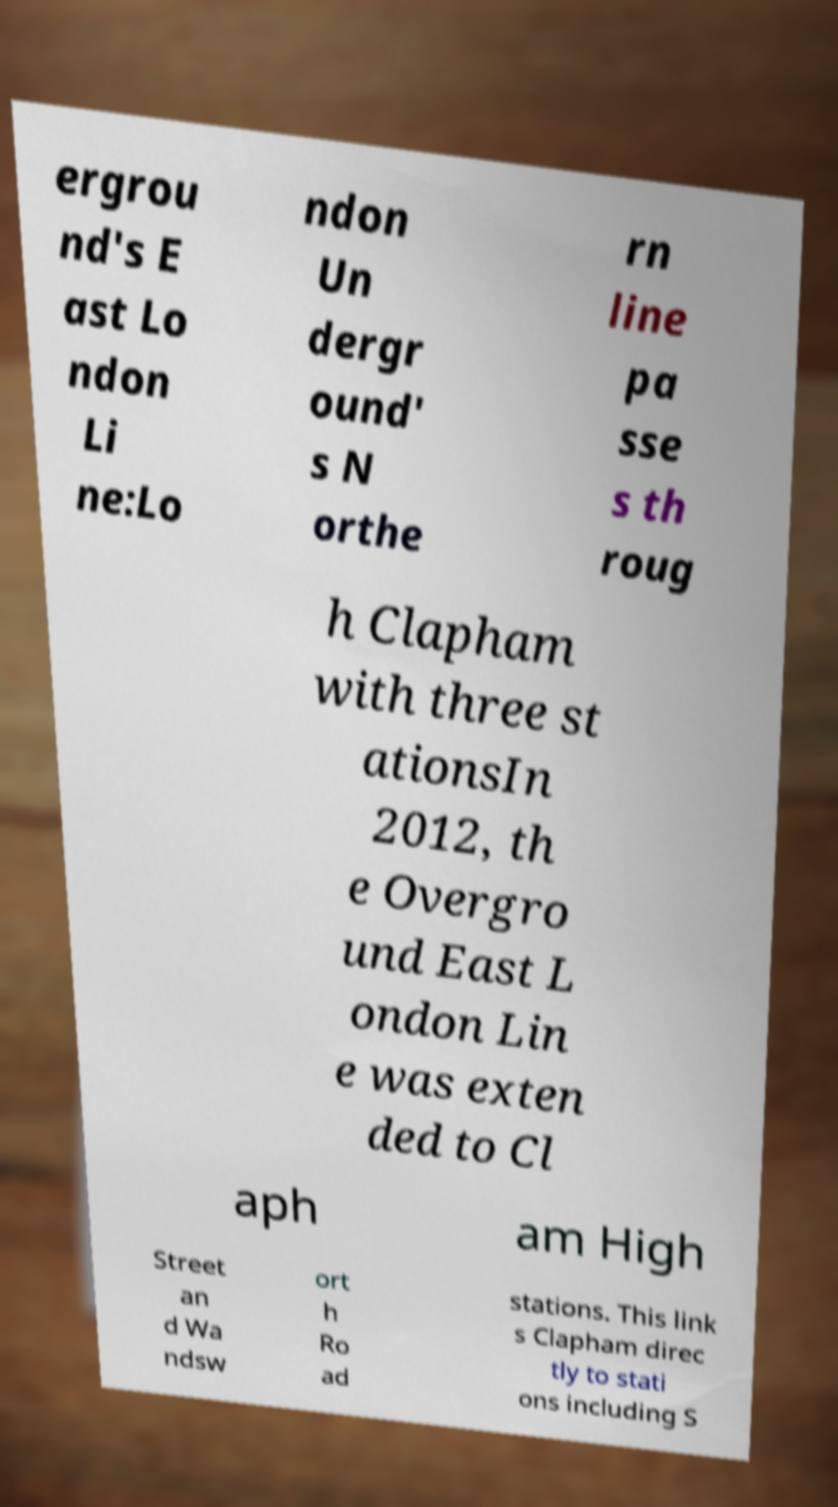Could you assist in decoding the text presented in this image and type it out clearly? ergrou nd's E ast Lo ndon Li ne:Lo ndon Un dergr ound' s N orthe rn line pa sse s th roug h Clapham with three st ationsIn 2012, th e Overgro und East L ondon Lin e was exten ded to Cl aph am High Street an d Wa ndsw ort h Ro ad stations. This link s Clapham direc tly to stati ons including S 